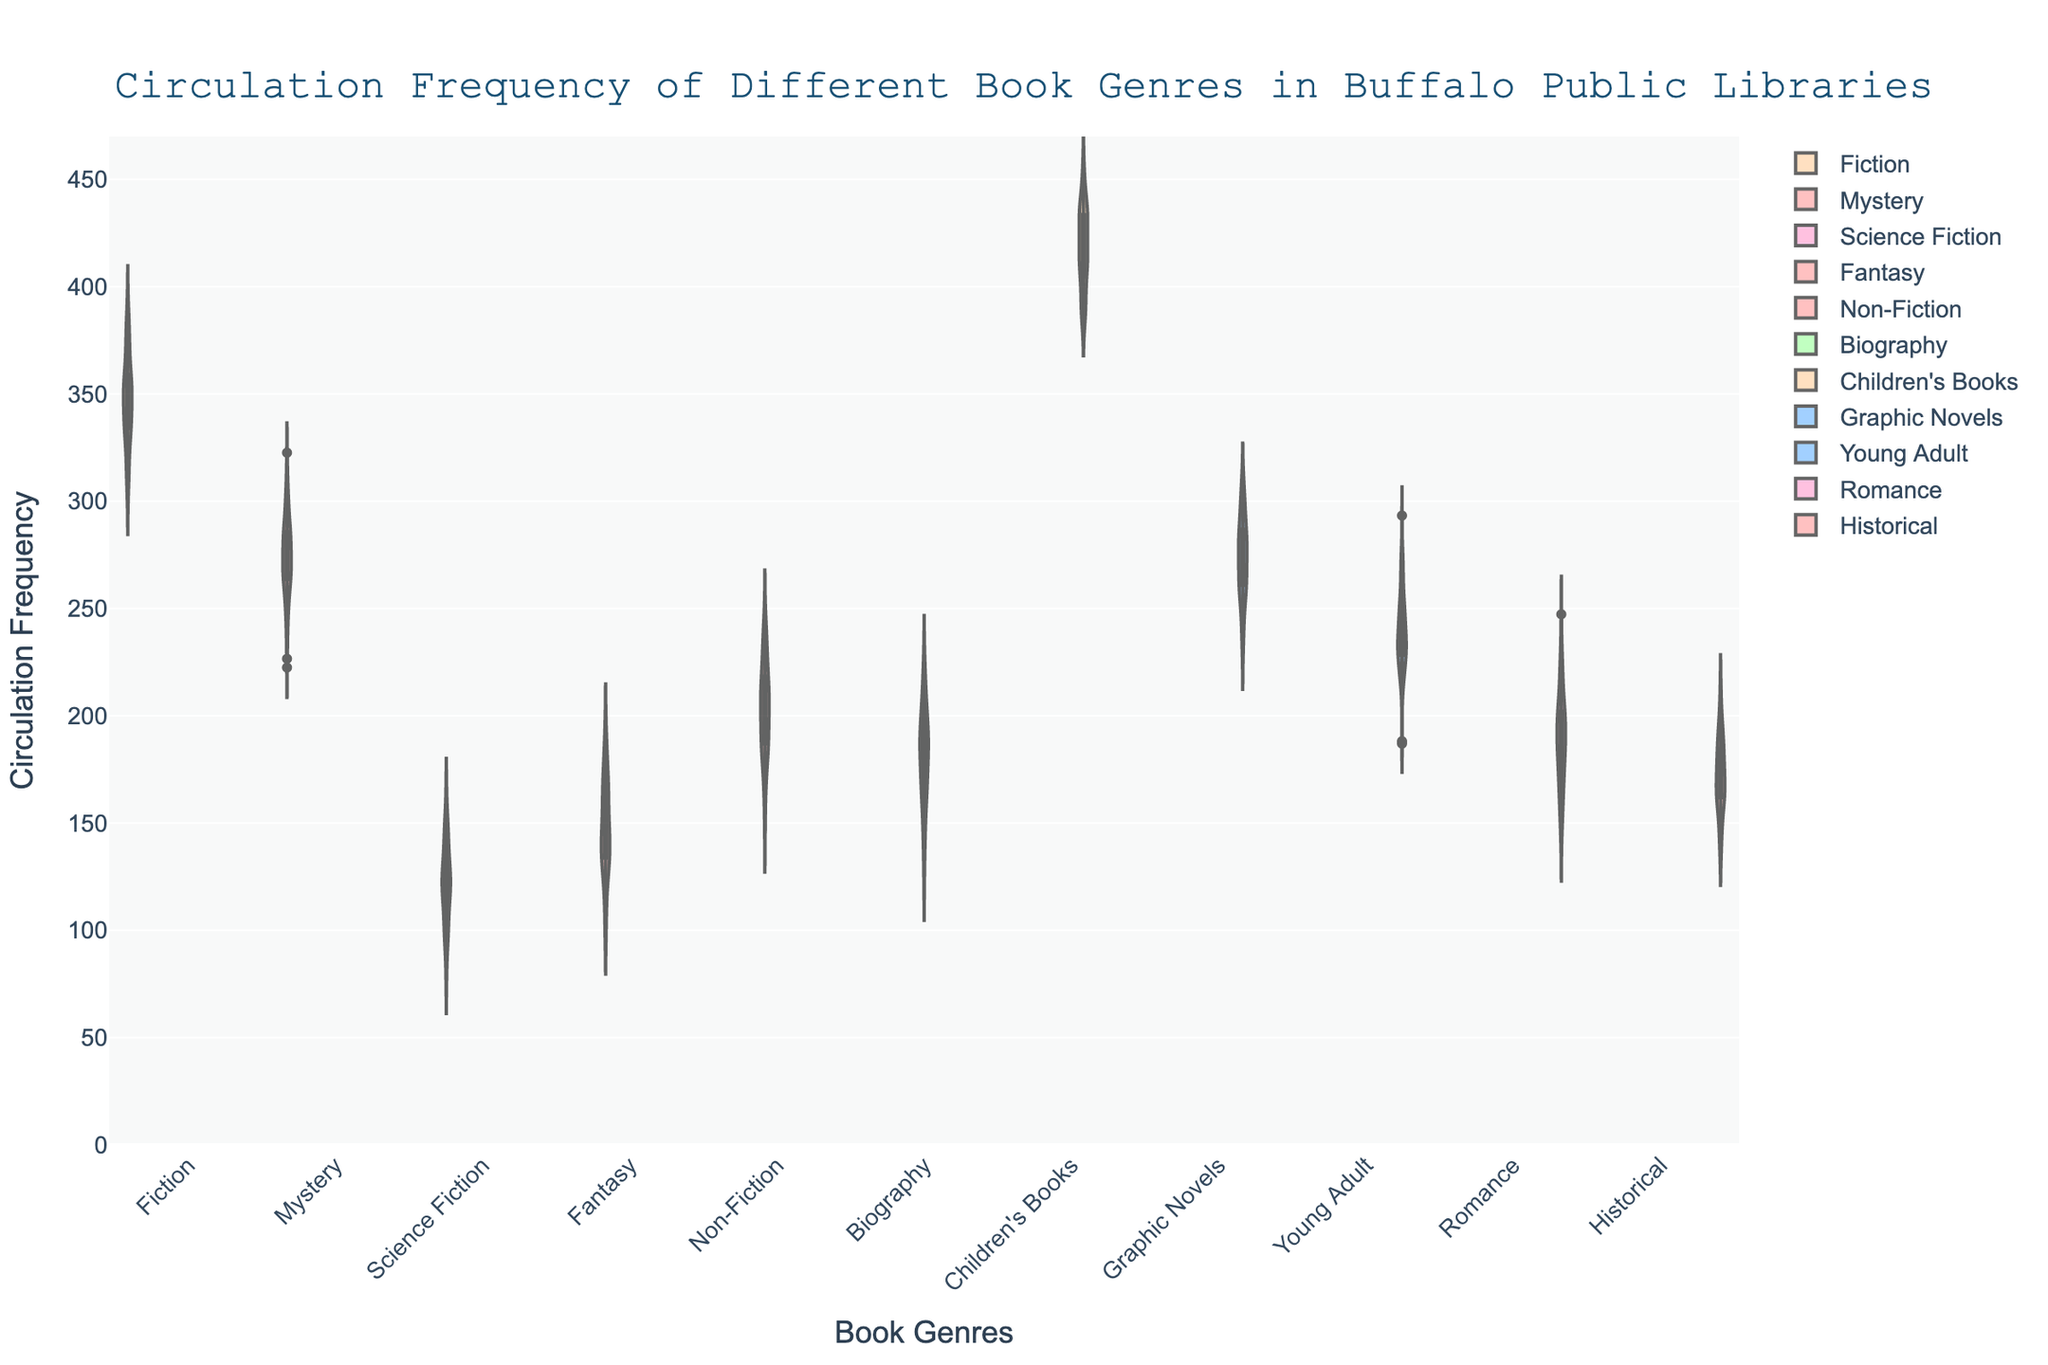What is the genre with the highest circulation frequency? The highest point in the chart, which represents the maximum circulation frequency, is for Children's Books.
Answer: Children's Books Which genre has the median circulation frequency, and what is that value? The median circulation value is found by looking at the center line of each violin plot. For Romance, the median value is 190.
Answer: Romance, 190 Which has a higher circulation frequency, Mystery or Romance books? By comparing the median lines' locations in the violin plots for Mystery and Romance, Mystery has a median value of 275 while Romance has 190.
Answer: Mystery How does the circulation frequency of Fiction compare to Non-Fiction? The median circulation line for Fiction is at 350, whereas for Non-Fiction, it is at 200. Fiction has a higher circulation frequency.
Answer: Fiction What is the range of circulation frequencies you can observe in the Fantasy genre? The vertical spread of the Fantasy violin plot shows values ranging roughly from 130 to 170.
Answer: 130 to 170 Which genre shows the least variation in circulation frequency? The genre with the narrowest violin plot, indicating less variation, appears to be Biography.
Answer: Biography Can you identify any genre where the average circulation frequency is the highest? The mean line, often highlighted in the plot, is highest for Children's Books, indicating the highest average circulation frequency.
Answer: Children's Books How does the variability of Science Fiction compare to Historical books? Observing the width of the violin plots for both genres, Science Fiction has a wider plot indicating higher variability, while Historical is narrower.
Answer: Science Fiction Which two genres have nearly identical circulation frequencies? By looking at the proximity of their median lines, Mystery and Graphic Novels both have median values close to 275.
Answer: Mystery and Graphic Novels On average, how much higher is the circulation frequency for Children's Books compared to Biographies? The average (mean) line for Children's Books is at 420, and for Biography, it is at 185. The difference is 420 - 185 = 235.
Answer: 235 